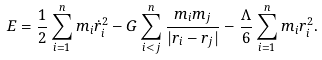Convert formula to latex. <formula><loc_0><loc_0><loc_500><loc_500>E = \frac { 1 } { 2 } \sum ^ { n } _ { i = 1 } m _ { i } \dot { r } ^ { 2 } _ { i } - G \sum ^ { n } _ { i < j } \frac { m _ { i } m _ { j } } { | { r } _ { i } - { r } _ { j } | } - \frac { \Lambda } { 6 } \sum ^ { n } _ { i = 1 } m _ { i } r ^ { 2 } _ { i } .</formula> 